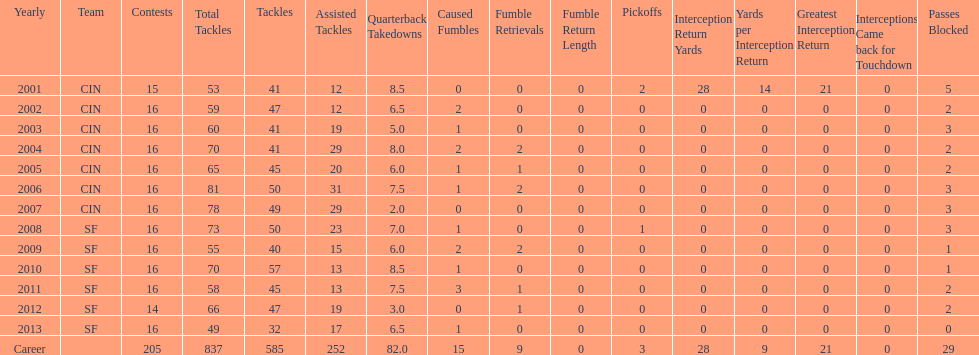How many years did he play where he did not recover a fumble? 7. 